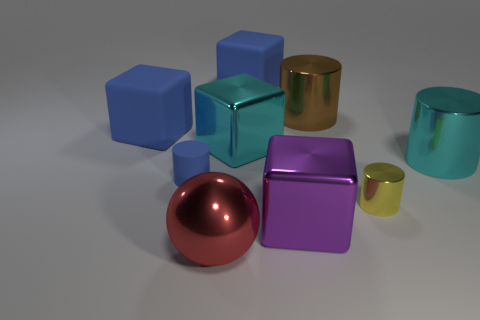Is the number of small blue cylinders left of the small blue matte cylinder the same as the number of tiny cylinders left of the large brown shiny object?
Your response must be concise. No. What color is the other cylinder that is the same size as the cyan metal cylinder?
Offer a very short reply. Brown. Is there a small rubber thing of the same color as the tiny matte cylinder?
Give a very brief answer. No. What number of objects are shiny objects that are in front of the cyan cube or brown cylinders?
Keep it short and to the point. 5. What number of other things are there of the same size as the yellow metal cylinder?
Make the answer very short. 1. What is the large cylinder in front of the big matte block that is on the left side of the matte object that is to the right of the red ball made of?
Ensure brevity in your answer.  Metal. How many blocks are small yellow shiny objects or brown shiny things?
Keep it short and to the point. 0. Is there anything else that is the same shape as the large red shiny thing?
Offer a terse response. No. Are there more big red spheres that are behind the purple cube than metal cylinders that are right of the large brown cylinder?
Offer a very short reply. No. How many small yellow metal objects are behind the big cyan shiny thing to the right of the tiny shiny object?
Provide a short and direct response. 0. 